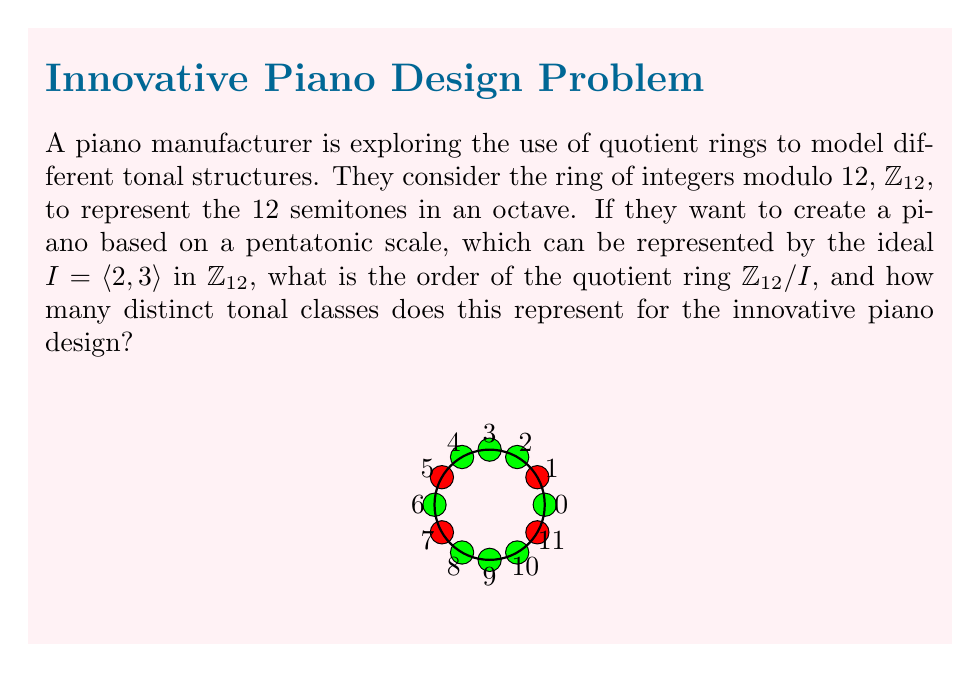Show me your answer to this math problem. Let's approach this step-by-step:

1) First, we need to understand what the ideal $I = \langle 2, 3 \rangle$ represents in $\mathbb{Z}_{12}$:
   $I = \{2a + 3b \mod 12 : a,b \in \mathbb{Z}\}$

2) To find the elements of $I$, let's calculate some combinations:
   $2 \cdot 0 + 3 \cdot 0 = 0 \mod 12$
   $2 \cdot 1 + 3 \cdot 0 = 2 \mod 12$
   $2 \cdot 0 + 3 \cdot 1 = 3 \mod 12$
   $2 \cdot 1 + 3 \cdot 1 = 5 \mod 12$
   $2 \cdot 2 + 3 \cdot 1 = 7 \mod 12$
   $2 \cdot 2 + 3 \cdot 2 = 10 \mod 12$

3) We can see that $I = \{0, 2, 3, 5, 7, 10\}$

4) The order of the quotient ring $\mathbb{Z}_{12}/I$ is equal to the number of cosets of $I$ in $\mathbb{Z}_{12}$, which is given by:
   $|\mathbb{Z}_{12}/I| = |\mathbb{Z}_{12}| / |I| = 12 / 6 = 2$

5) This means there are 2 distinct cosets, which represent 2 tonal classes:
   $[0] = \{0, 2, 3, 5, 7, 10\}$
   $[1] = \{1, 4, 6, 8, 9, 11\}$

6) These two classes correspond to the notes in the pentatonic scale (represented by $[0]$) and the notes not in the scale (represented by $[1]$).

Therefore, this quotient ring structure represents 2 distinct tonal classes for the innovative piano design: the pentatonic scale notes and the non-pentatonic scale notes.
Answer: 2 